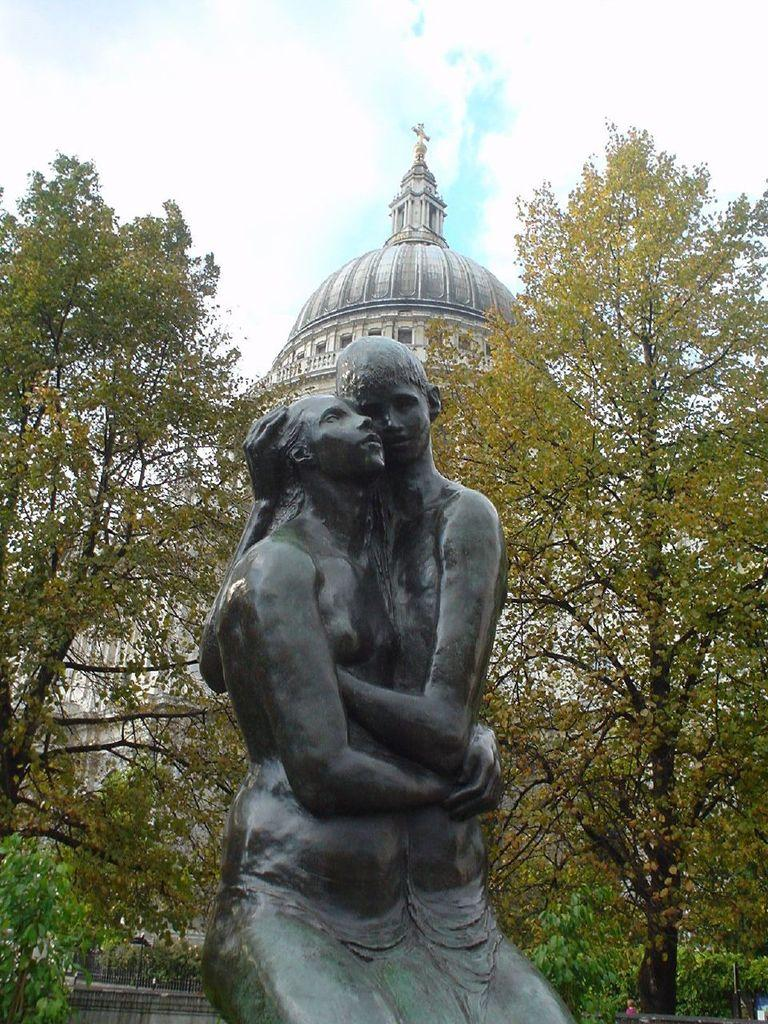What is the main subject of the image? There is a sculpture in the image. What can be seen behind the sculpture? There are two trees behind the sculpture. What type of building is visible in the background? There is a church in the background of the image. What type of desk can be seen in the image? There is no desk present in the image. How many hens are visible in the image? There are no hens present in the image. 